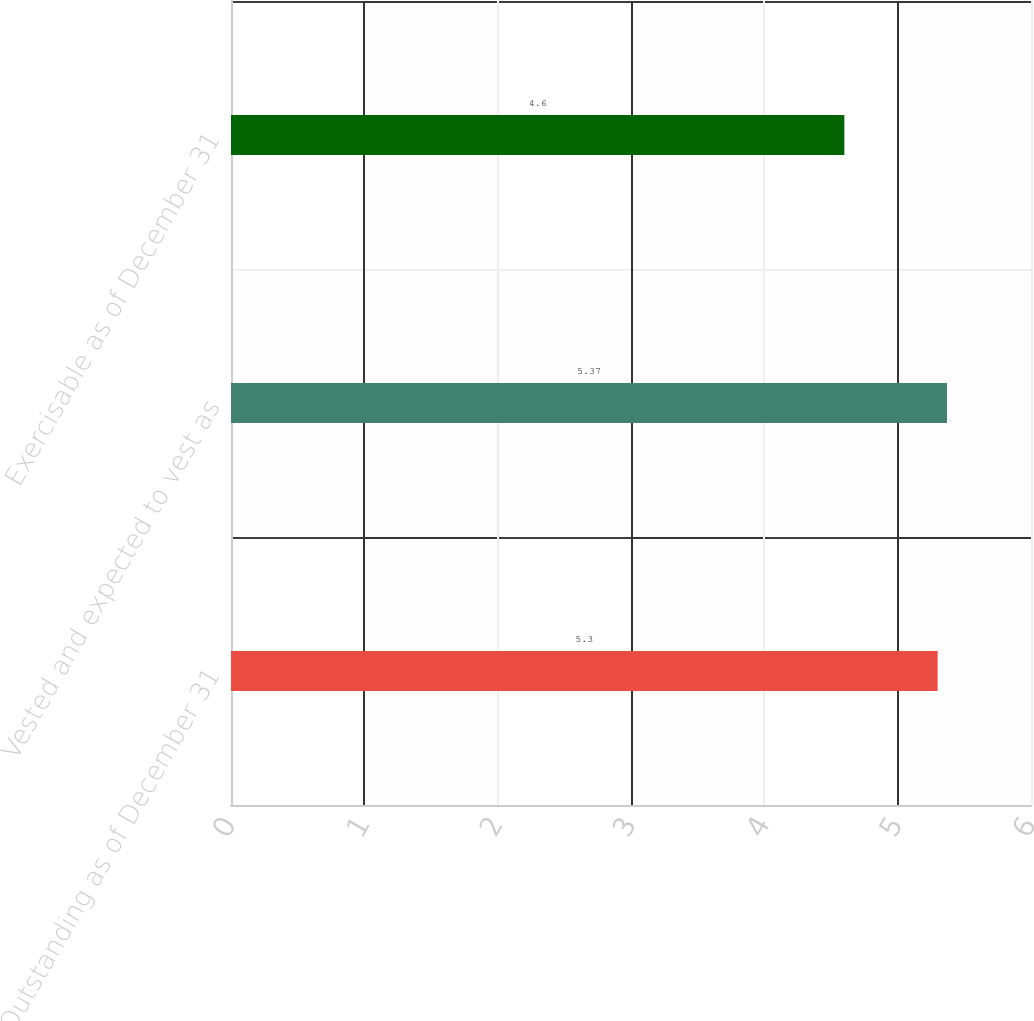Convert chart. <chart><loc_0><loc_0><loc_500><loc_500><bar_chart><fcel>Outstanding as of December 31<fcel>Vested and expected to vest as<fcel>Exercisable as of December 31<nl><fcel>5.3<fcel>5.37<fcel>4.6<nl></chart> 